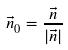<formula> <loc_0><loc_0><loc_500><loc_500>\vec { n } _ { 0 } = \frac { \vec { n } } { | \vec { n } | }</formula> 